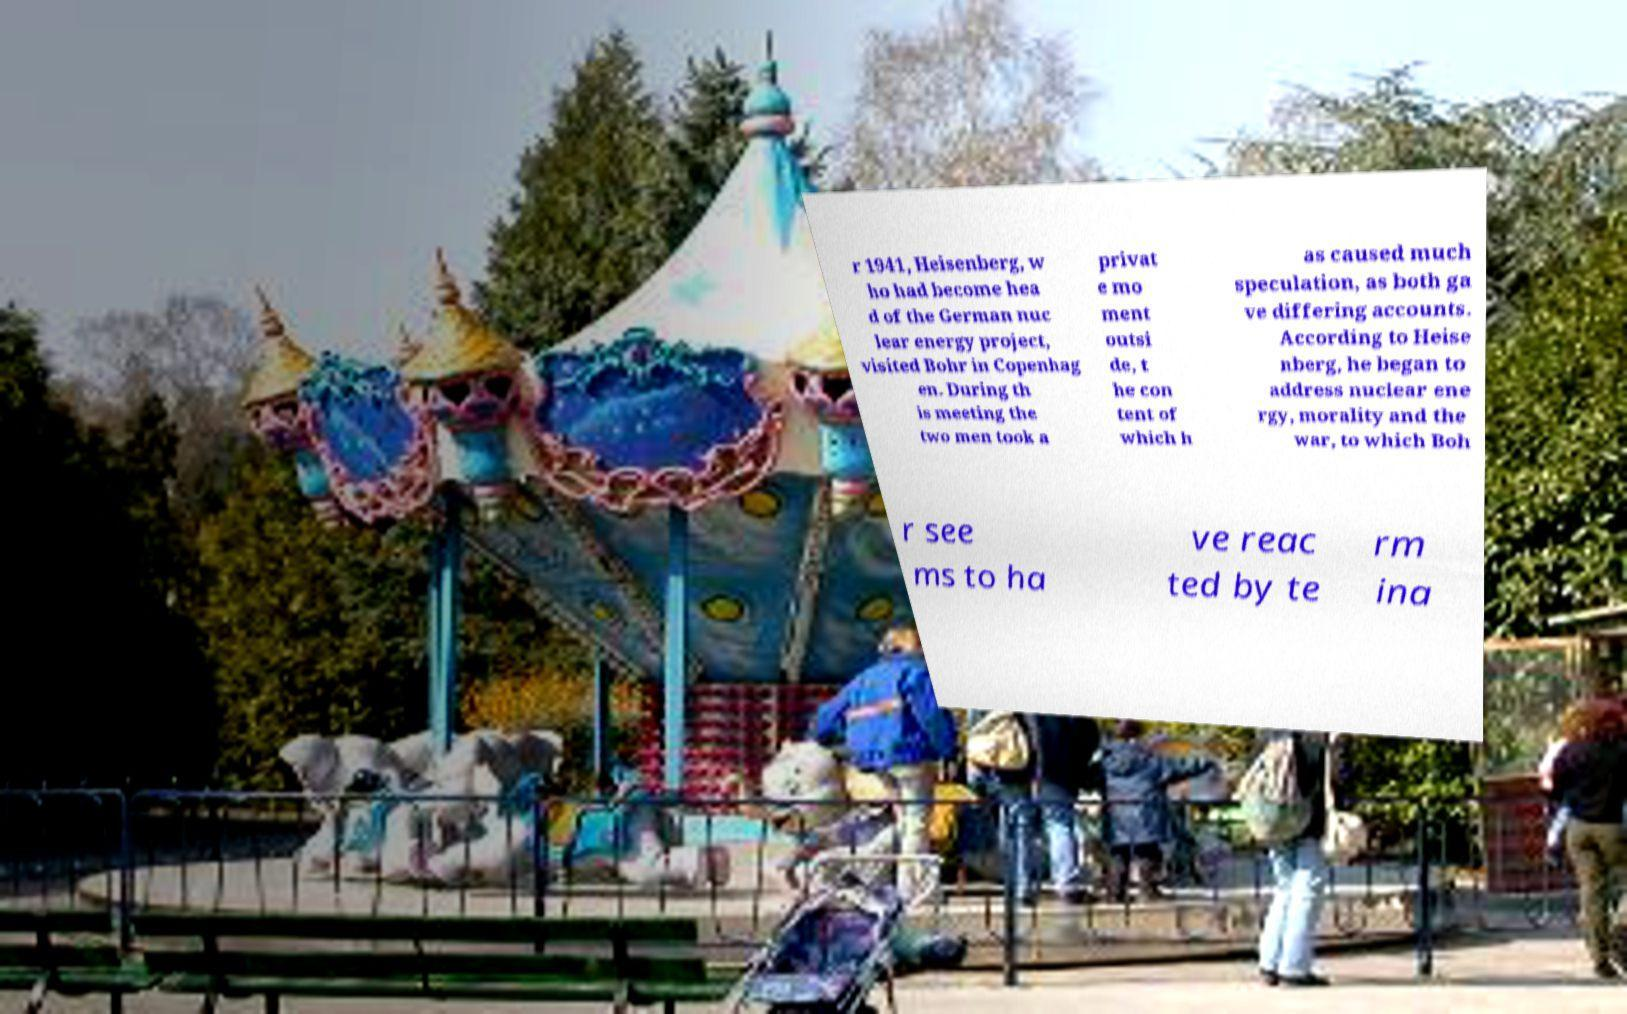What messages or text are displayed in this image? I need them in a readable, typed format. r 1941, Heisenberg, w ho had become hea d of the German nuc lear energy project, visited Bohr in Copenhag en. During th is meeting the two men took a privat e mo ment outsi de, t he con tent of which h as caused much speculation, as both ga ve differing accounts. According to Heise nberg, he began to address nuclear ene rgy, morality and the war, to which Boh r see ms to ha ve reac ted by te rm ina 